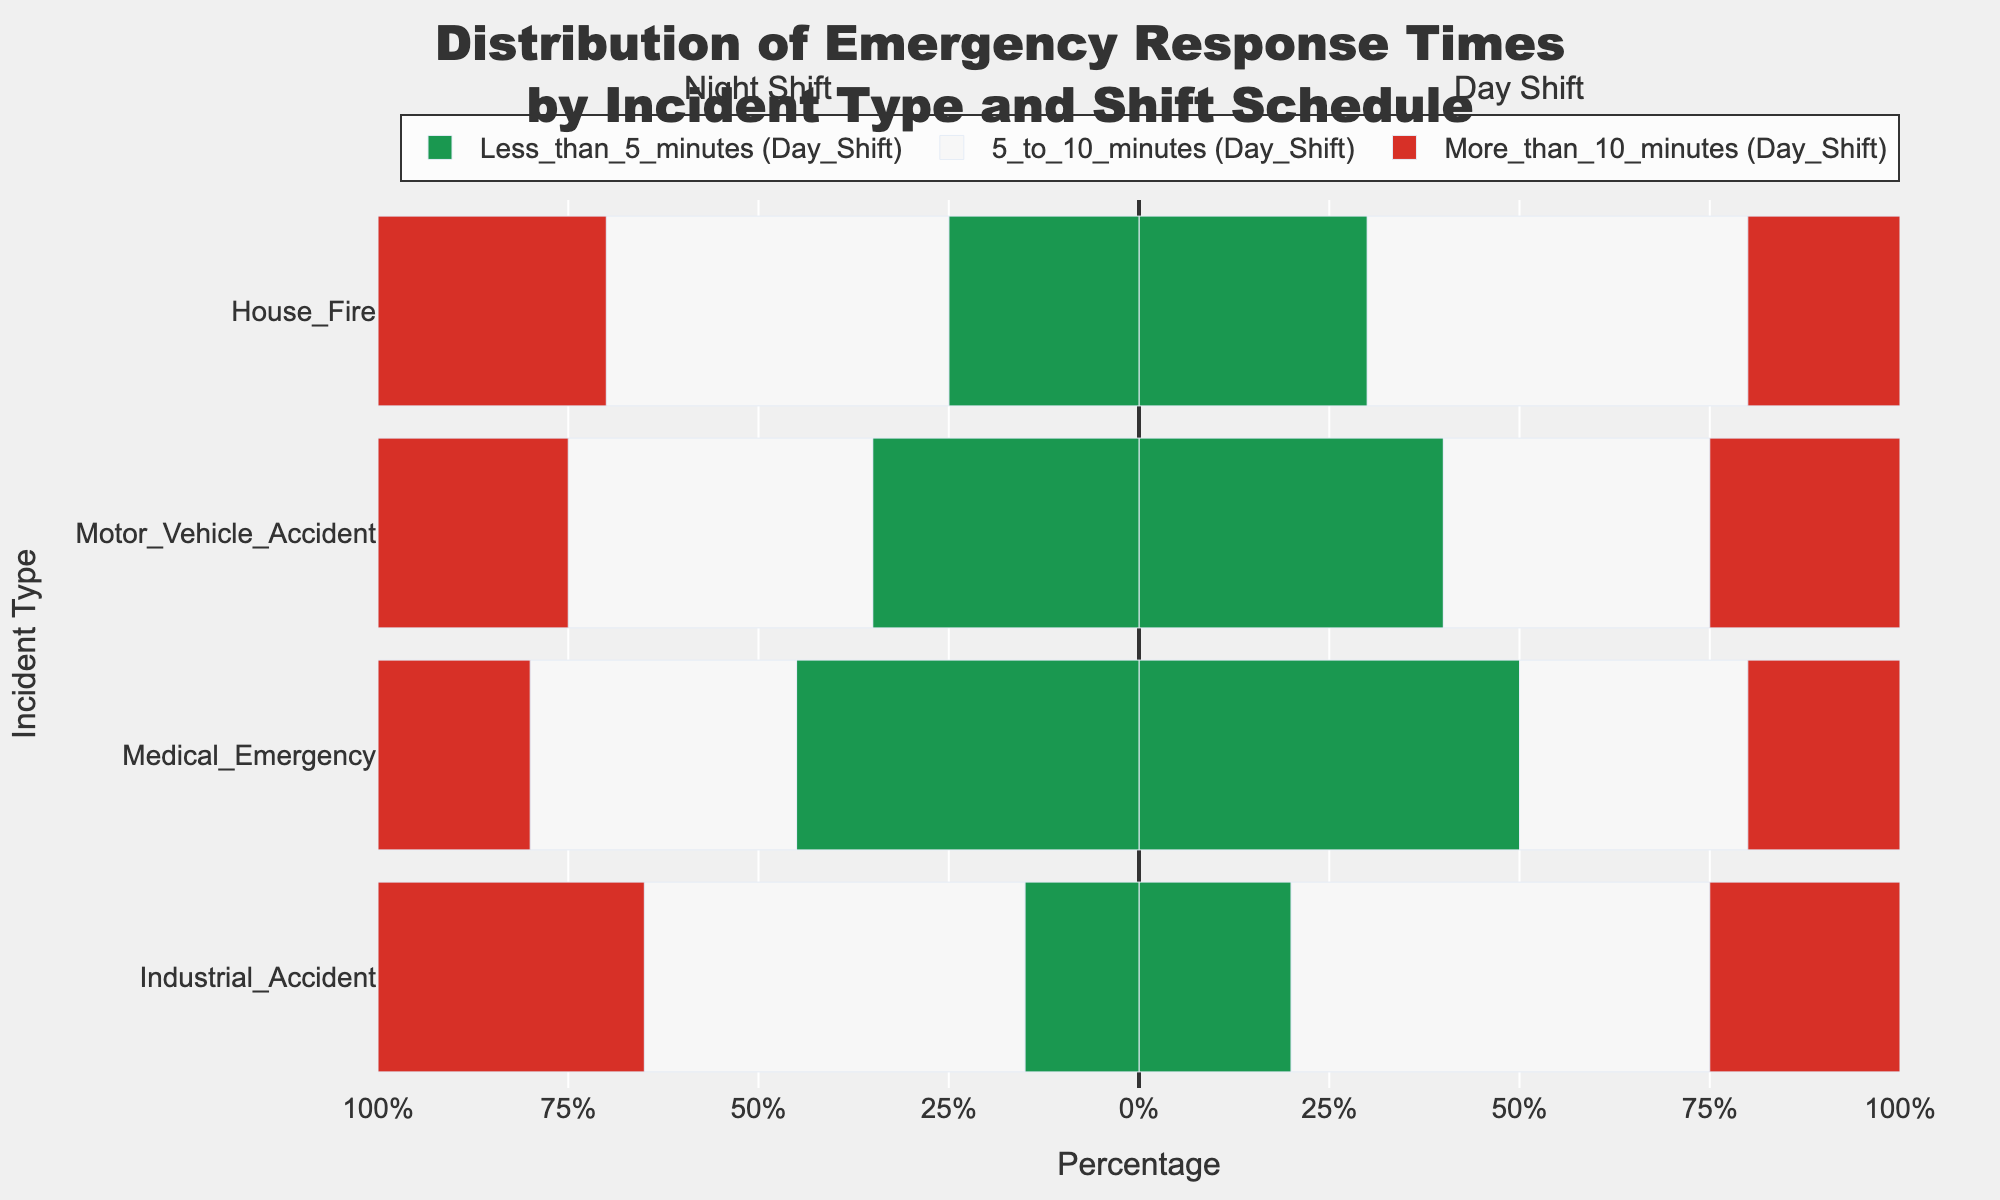What percentage of house fires during the day shift had response times of less than 5 minutes? To find this, look at the green bar section for "House Fire" under "Day Shift". The percentage value given for "Less_than_5_minutes" will be the answer.
Answer: 30% Which shift had a higher percentage of responses taking more than 10 minutes during medical emergencies? Compare the red bar sections for "Medical Emergency" under both "Day Shift" and "Night Shift". The longer red bar represents the higher percentage.
Answer: Night Shift What is the difference in percentage between day and night shifts for motor vehicle accidents with response times between 5 to 10 minutes? Find the lengths of the grey bars for "5_to_10_minutes" under "Motor Vehicle Accident" for both shifts. Subtract the night shift percentage from the day shift percentage.
Answer: 5% During the night shift, which incident type had the highest percentage of responses within 5 to 10 minutes? Identify the grey bars for "5_to_10_minutes" under "Night Shift" across incident types. The longest grey bar indicates the highest percentage.
Answer: Industrial Accident For industrial accidents, how do the combined percentages of less than 5 minutes and more than 10 minutes responses compare between the day and night shifts? Sum the green and red bar sections for both "Day Shift" and "Night Shift" for "Industrial Accident". Compare these sums.
Answer: 45% (Day) vs. 50% (Night) Which incident type had a greater percentage of responses taking less than 5 minutes during the day shift compared to the night shift? Compare the green bar sections for each incident under both shifts. Identify the incident type where the green bar is longer during the day shift than at night.
Answer: Motor Vehicle Accident What is the combined percentage of less than 5 minutes responses for house fires across both shifts? Add the percentages of the green bar sections for "Less_than_5_minutes" under "House Fire" for both shifts.
Answer: 55% Among all incident types during the night shift, which one had the smallest percentage of responses taking more than 10 minutes? Compare the red bar sections under "Night Shift" for all incident types. The shortest red bar indicates the smallest percentage.
Answer: Medical Emergency 